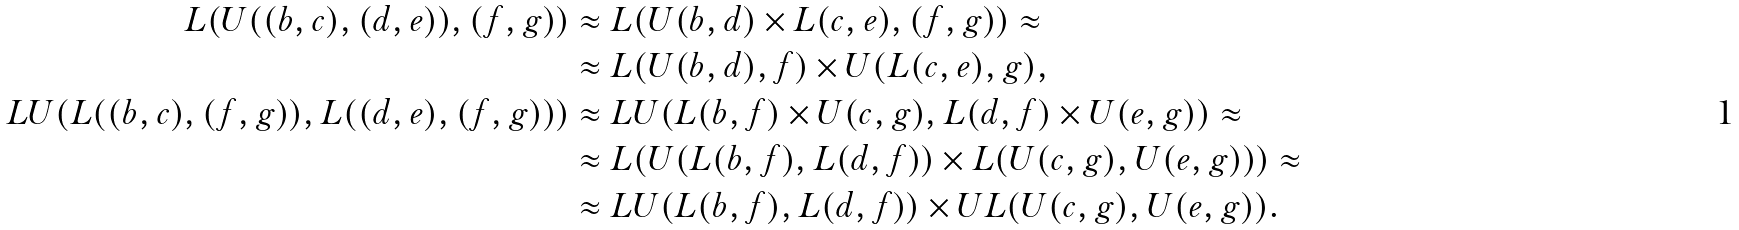Convert formula to latex. <formula><loc_0><loc_0><loc_500><loc_500>L ( U ( ( b , c ) , ( d , e ) ) , ( f , g ) ) & \approx L ( U ( b , d ) \times L ( c , e ) , ( f , g ) ) \approx \\ & \approx L ( U ( b , d ) , f ) \times U ( L ( c , e ) , g ) , \\ L U ( L ( ( b , c ) , ( f , g ) ) , L ( ( d , e ) , ( f , g ) ) ) & \approx L U ( L ( b , f ) \times U ( c , g ) , L ( d , f ) \times U ( e , g ) ) \approx \\ & \approx L ( U ( L ( b , f ) , L ( d , f ) ) \times L ( U ( c , g ) , U ( e , g ) ) ) \approx \\ & \approx L U ( L ( b , f ) , L ( d , f ) ) \times U L ( U ( c , g ) , U ( e , g ) ) .</formula> 